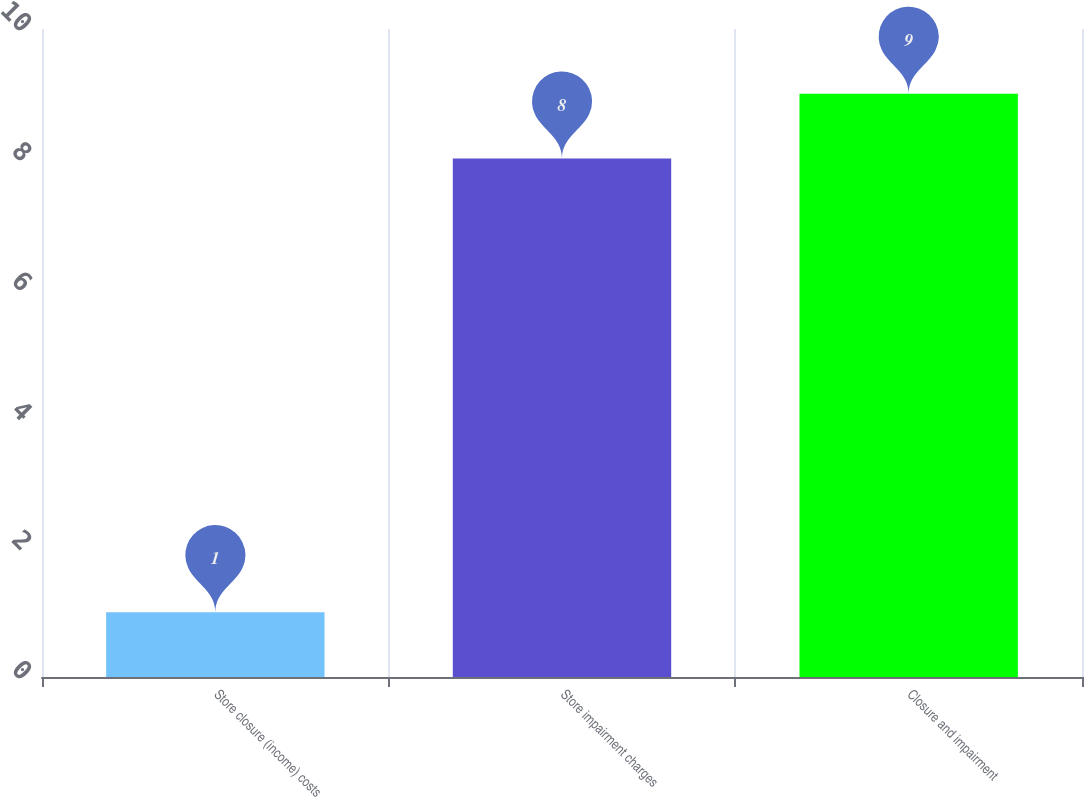Convert chart to OTSL. <chart><loc_0><loc_0><loc_500><loc_500><bar_chart><fcel>Store closure (income) costs<fcel>Store impairment charges<fcel>Closure and impairment<nl><fcel>1<fcel>8<fcel>9<nl></chart> 